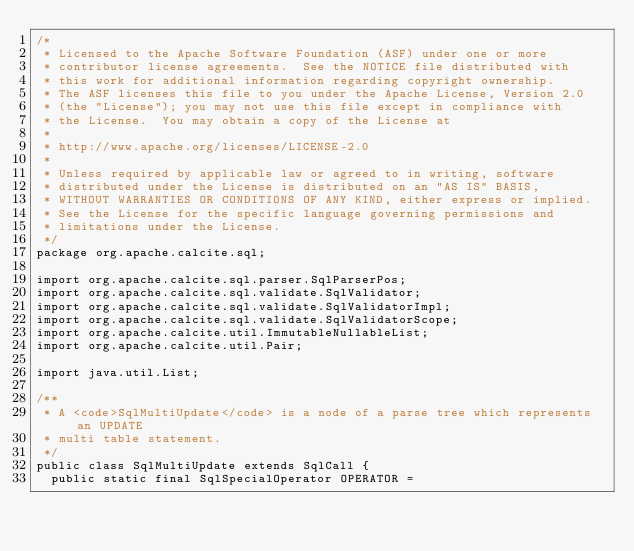<code> <loc_0><loc_0><loc_500><loc_500><_Java_>/*
 * Licensed to the Apache Software Foundation (ASF) under one or more
 * contributor license agreements.  See the NOTICE file distributed with
 * this work for additional information regarding copyright ownership.
 * The ASF licenses this file to you under the Apache License, Version 2.0
 * (the "License"); you may not use this file except in compliance with
 * the License.  You may obtain a copy of the License at
 *
 * http://www.apache.org/licenses/LICENSE-2.0
 *
 * Unless required by applicable law or agreed to in writing, software
 * distributed under the License is distributed on an "AS IS" BASIS,
 * WITHOUT WARRANTIES OR CONDITIONS OF ANY KIND, either express or implied.
 * See the License for the specific language governing permissions and
 * limitations under the License.
 */
package org.apache.calcite.sql;

import org.apache.calcite.sql.parser.SqlParserPos;
import org.apache.calcite.sql.validate.SqlValidator;
import org.apache.calcite.sql.validate.SqlValidatorImpl;
import org.apache.calcite.sql.validate.SqlValidatorScope;
import org.apache.calcite.util.ImmutableNullableList;
import org.apache.calcite.util.Pair;

import java.util.List;

/**
 * A <code>SqlMultiUpdate</code> is a node of a parse tree which represents an UPDATE
 * multi table statement.
 */
public class SqlMultiUpdate extends SqlCall {
  public static final SqlSpecialOperator OPERATOR =</code> 